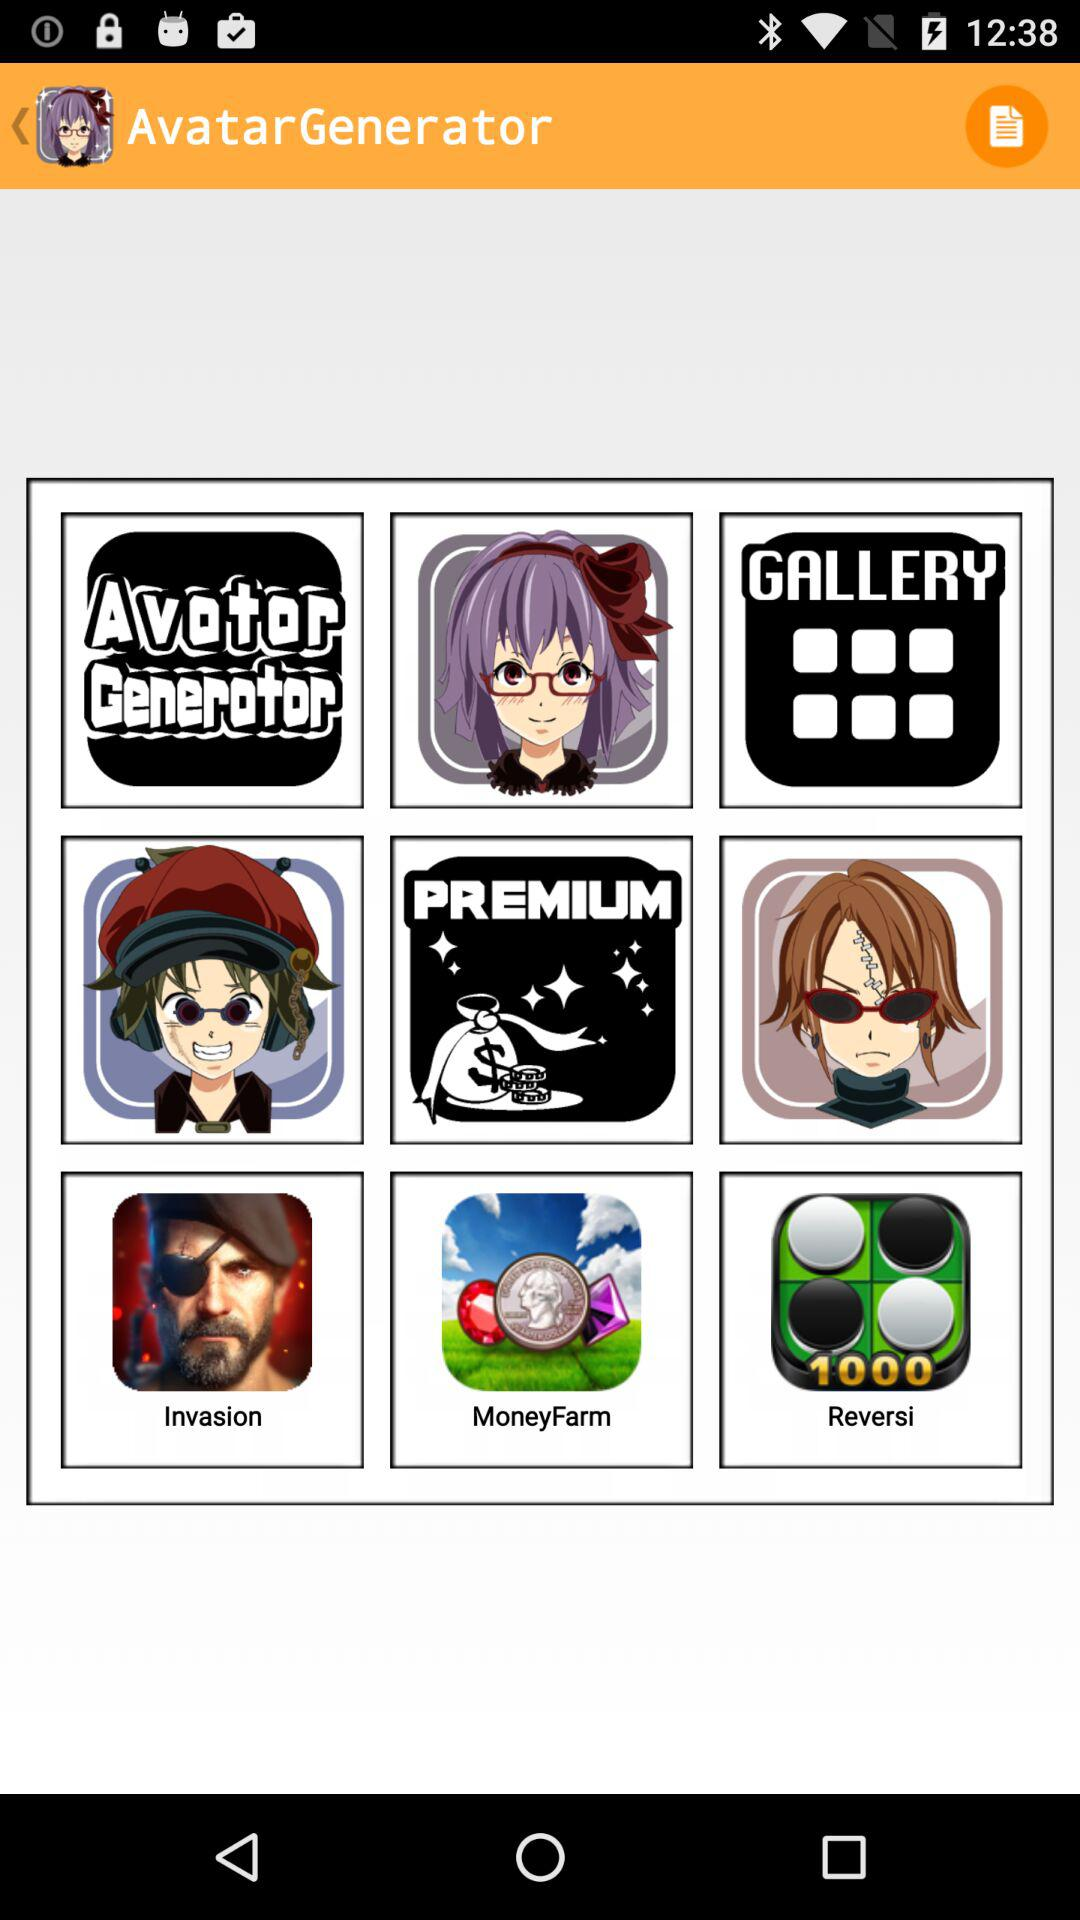What is the application name? The application name is "AvatarGenerator". 